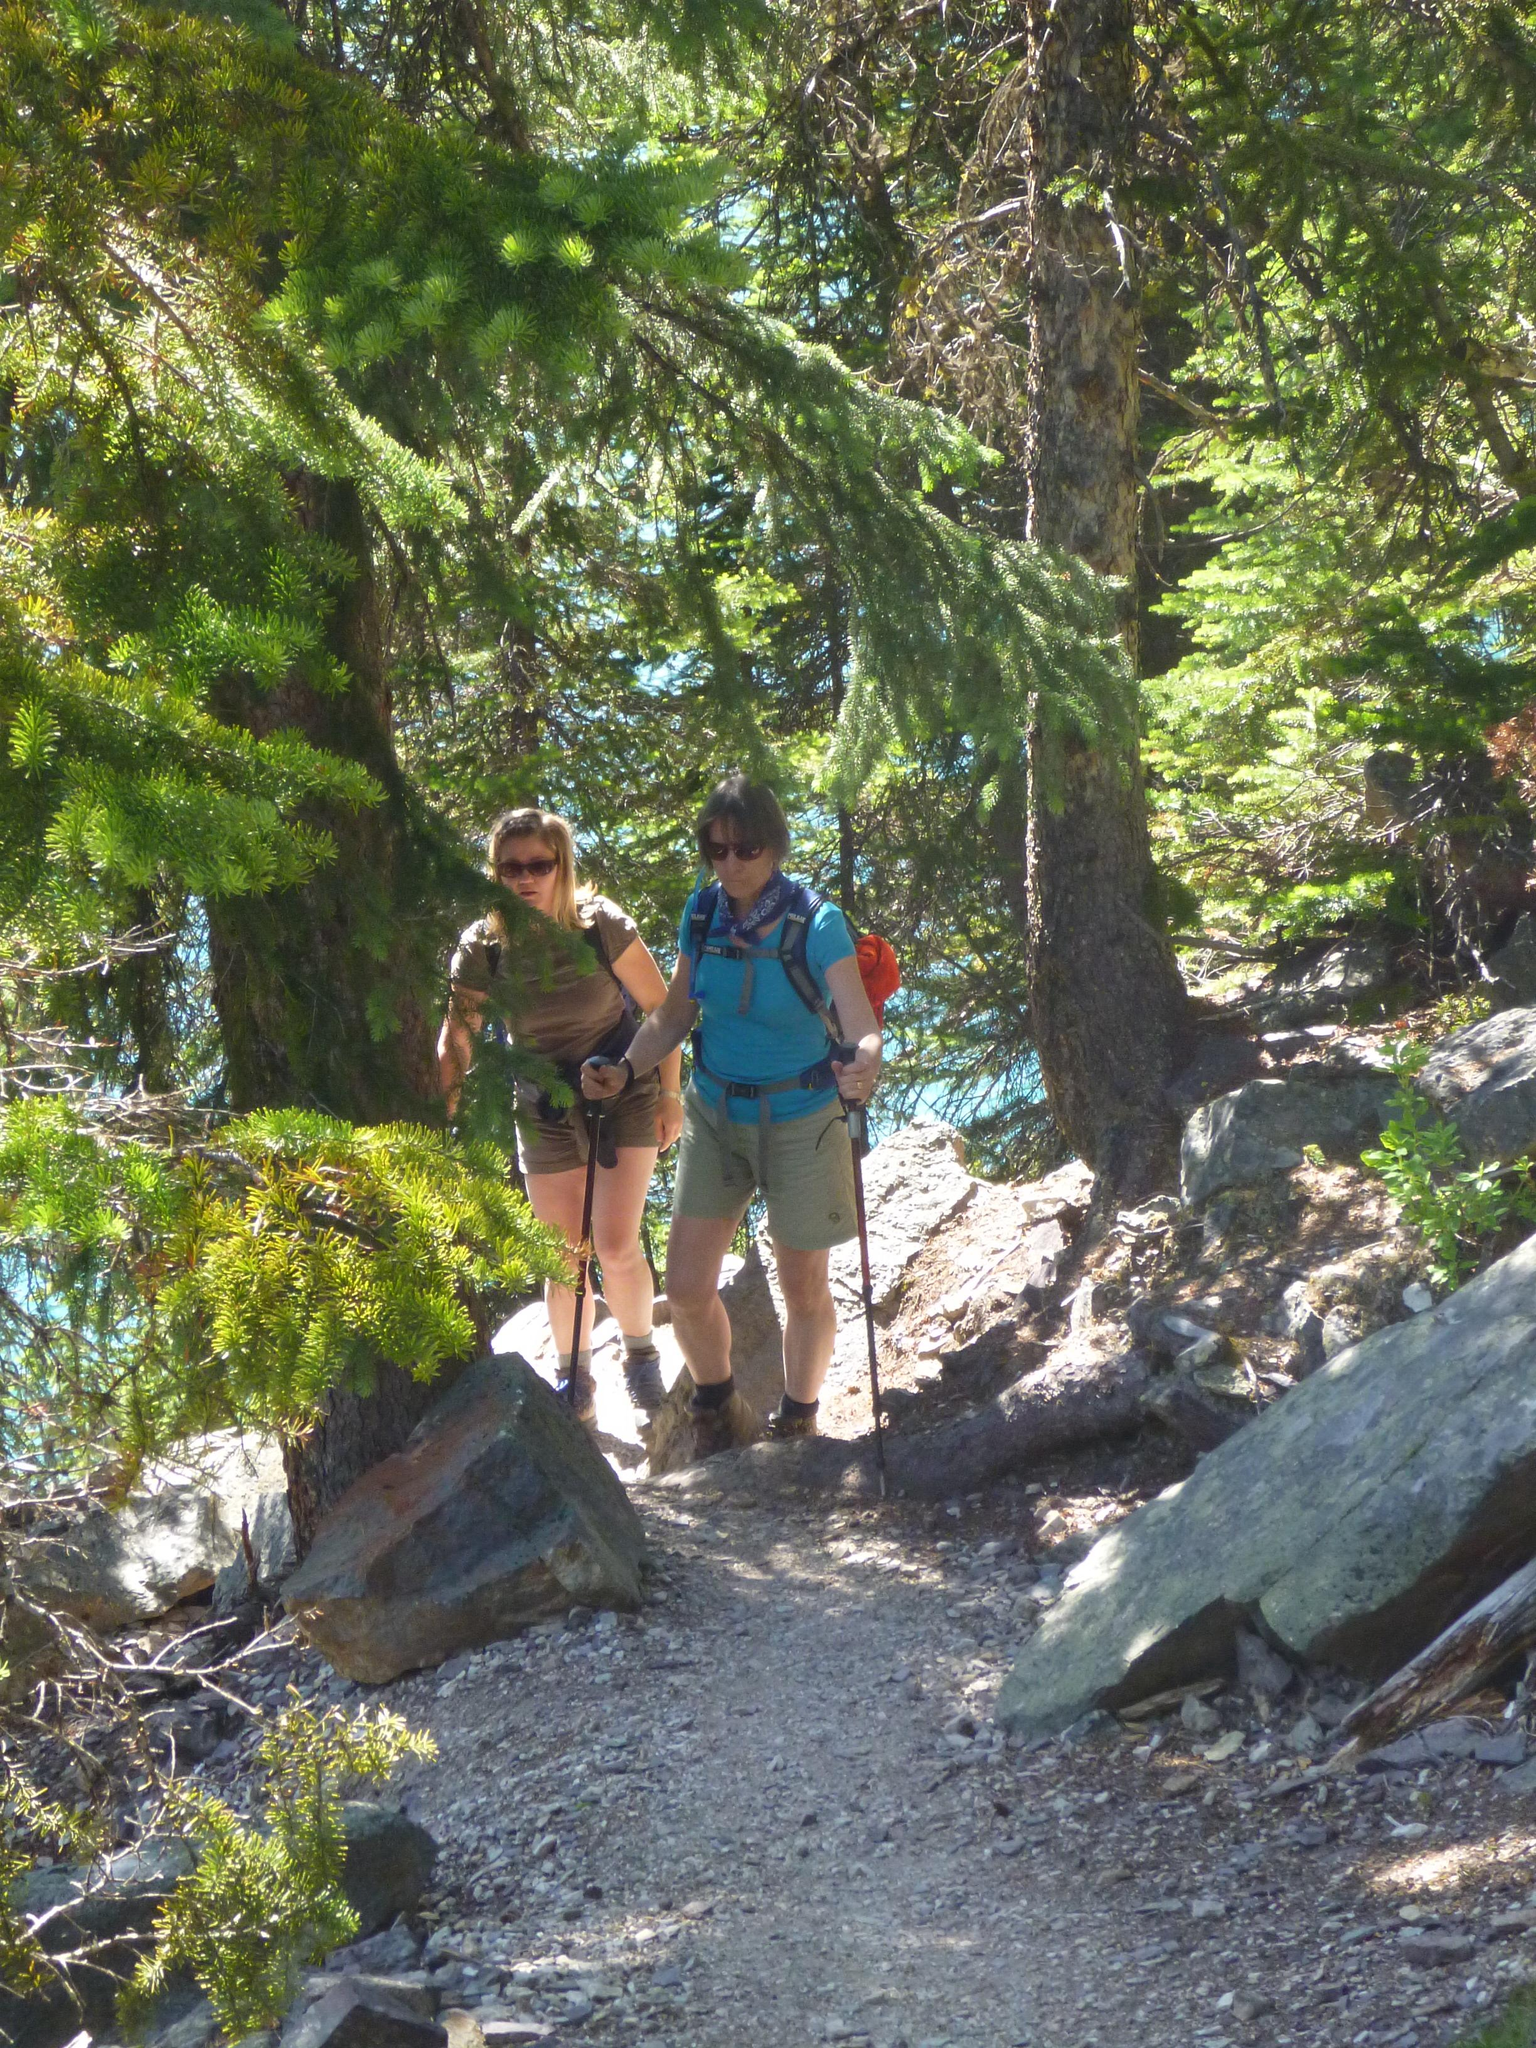Who is present in the image? There are people in the image. What are the people wearing? The people are wearing glasses. What are the people carrying? The people are carrying bags. What are the people holding? The people are holding sticks. What can be seen in the background of the image? There are trees and rocks in the background of the image. What is visible at the bottom of the image? There is ground visible at the bottom of the image. What type of button can be seen on the trees in the image? There are no buttons present on the trees in the image; they are natural trees. 